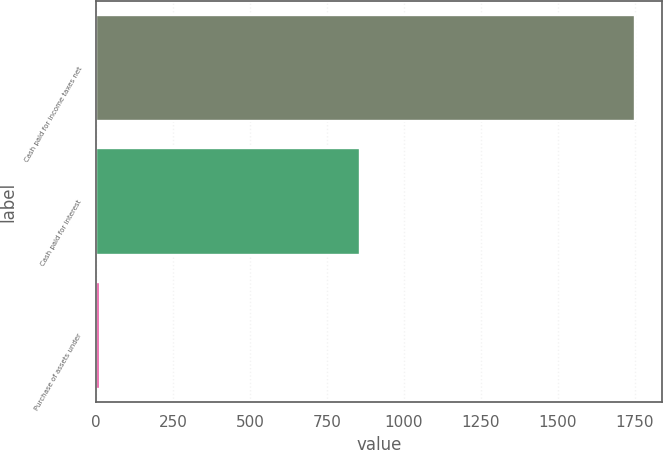Convert chart. <chart><loc_0><loc_0><loc_500><loc_500><bar_chart><fcel>Cash paid for income taxes net<fcel>Cash paid for interest<fcel>Purchase of assets under<nl><fcel>1750<fcel>856<fcel>12<nl></chart> 